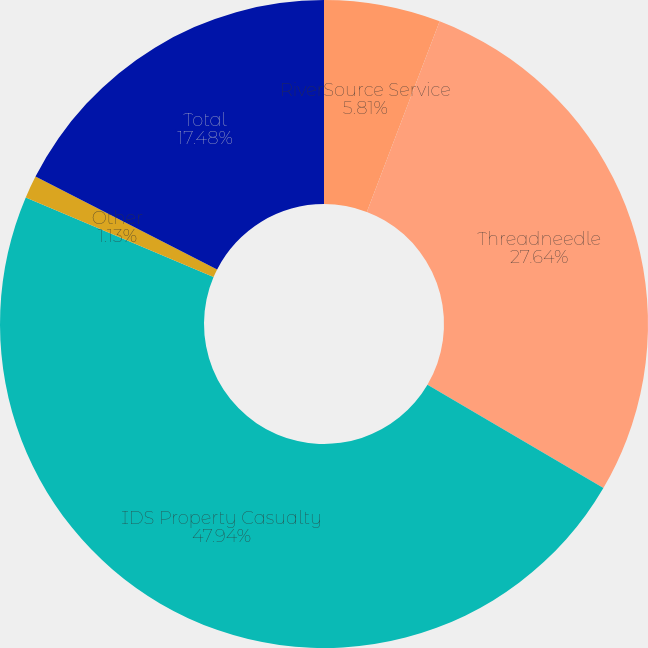<chart> <loc_0><loc_0><loc_500><loc_500><pie_chart><fcel>RiverSource Service<fcel>Threadneedle<fcel>IDS Property Casualty<fcel>Other<fcel>Total<nl><fcel>5.81%<fcel>27.64%<fcel>47.94%<fcel>1.13%<fcel>17.48%<nl></chart> 